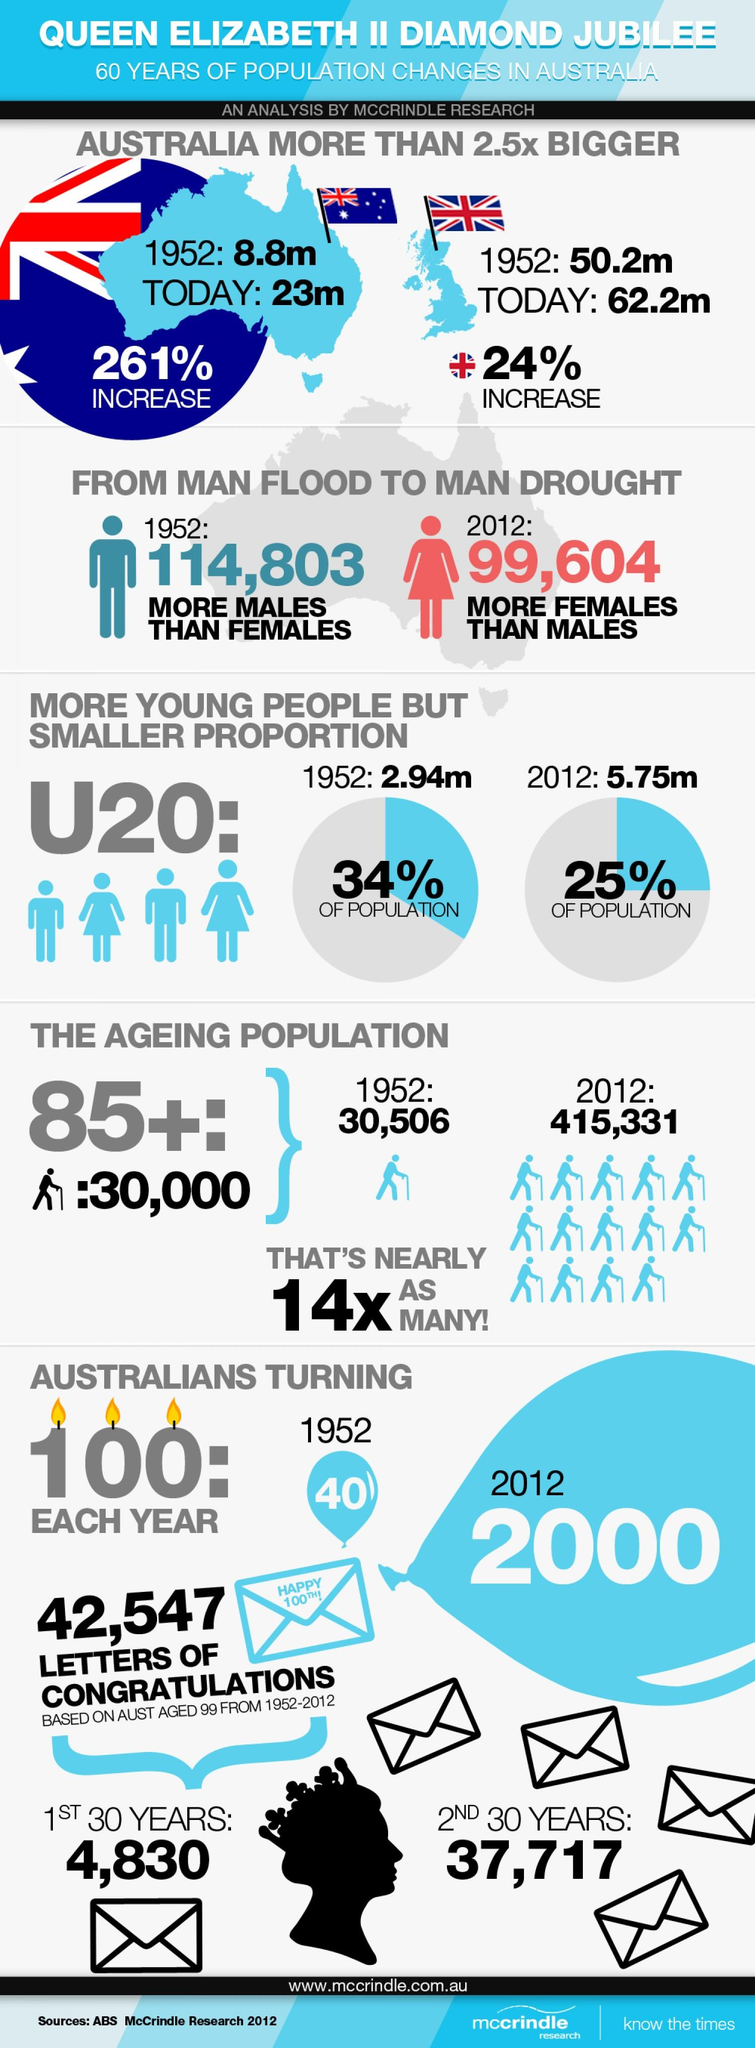Mention a couple of crucial points in this snapshot. In 2012, the number of people who turned 100 years old was 2000. The aging population is estimated to be approximately 30,000, with a focus on those aged 85 and above. In the past 60 years, the population of individuals under the age of 20 has decreased by a significant percentage. The population increase in Australia from 1952 to today is 261%. In 2012, it was estimated that approximately 25% of the global population was under the age of 20. 